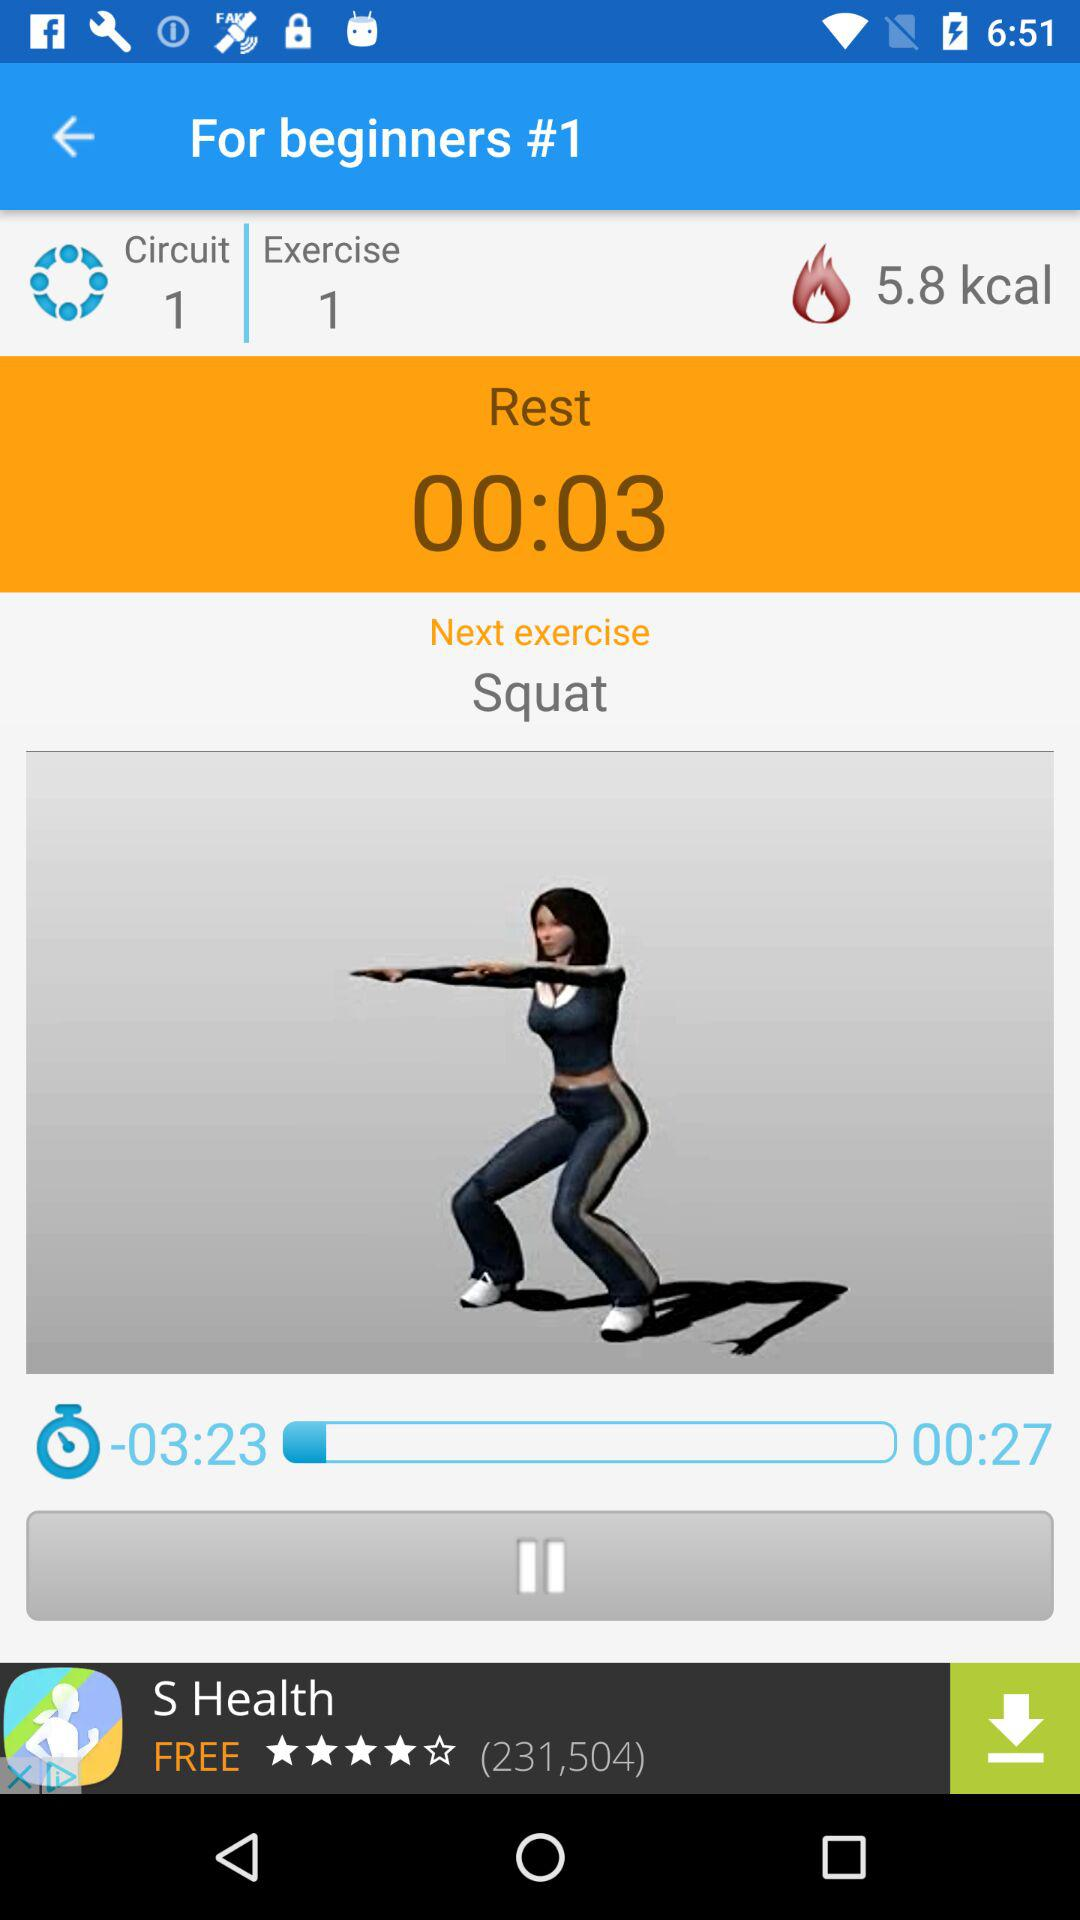How long is the resting time? The resting time is 3 seconds. 